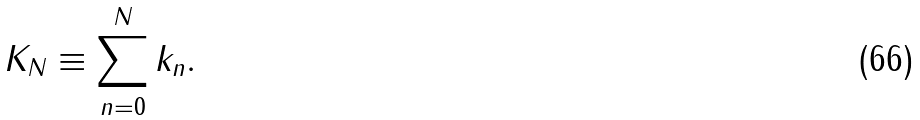Convert formula to latex. <formula><loc_0><loc_0><loc_500><loc_500>K _ { N } \equiv \sum _ { n = 0 } ^ { N } k _ { n } .</formula> 